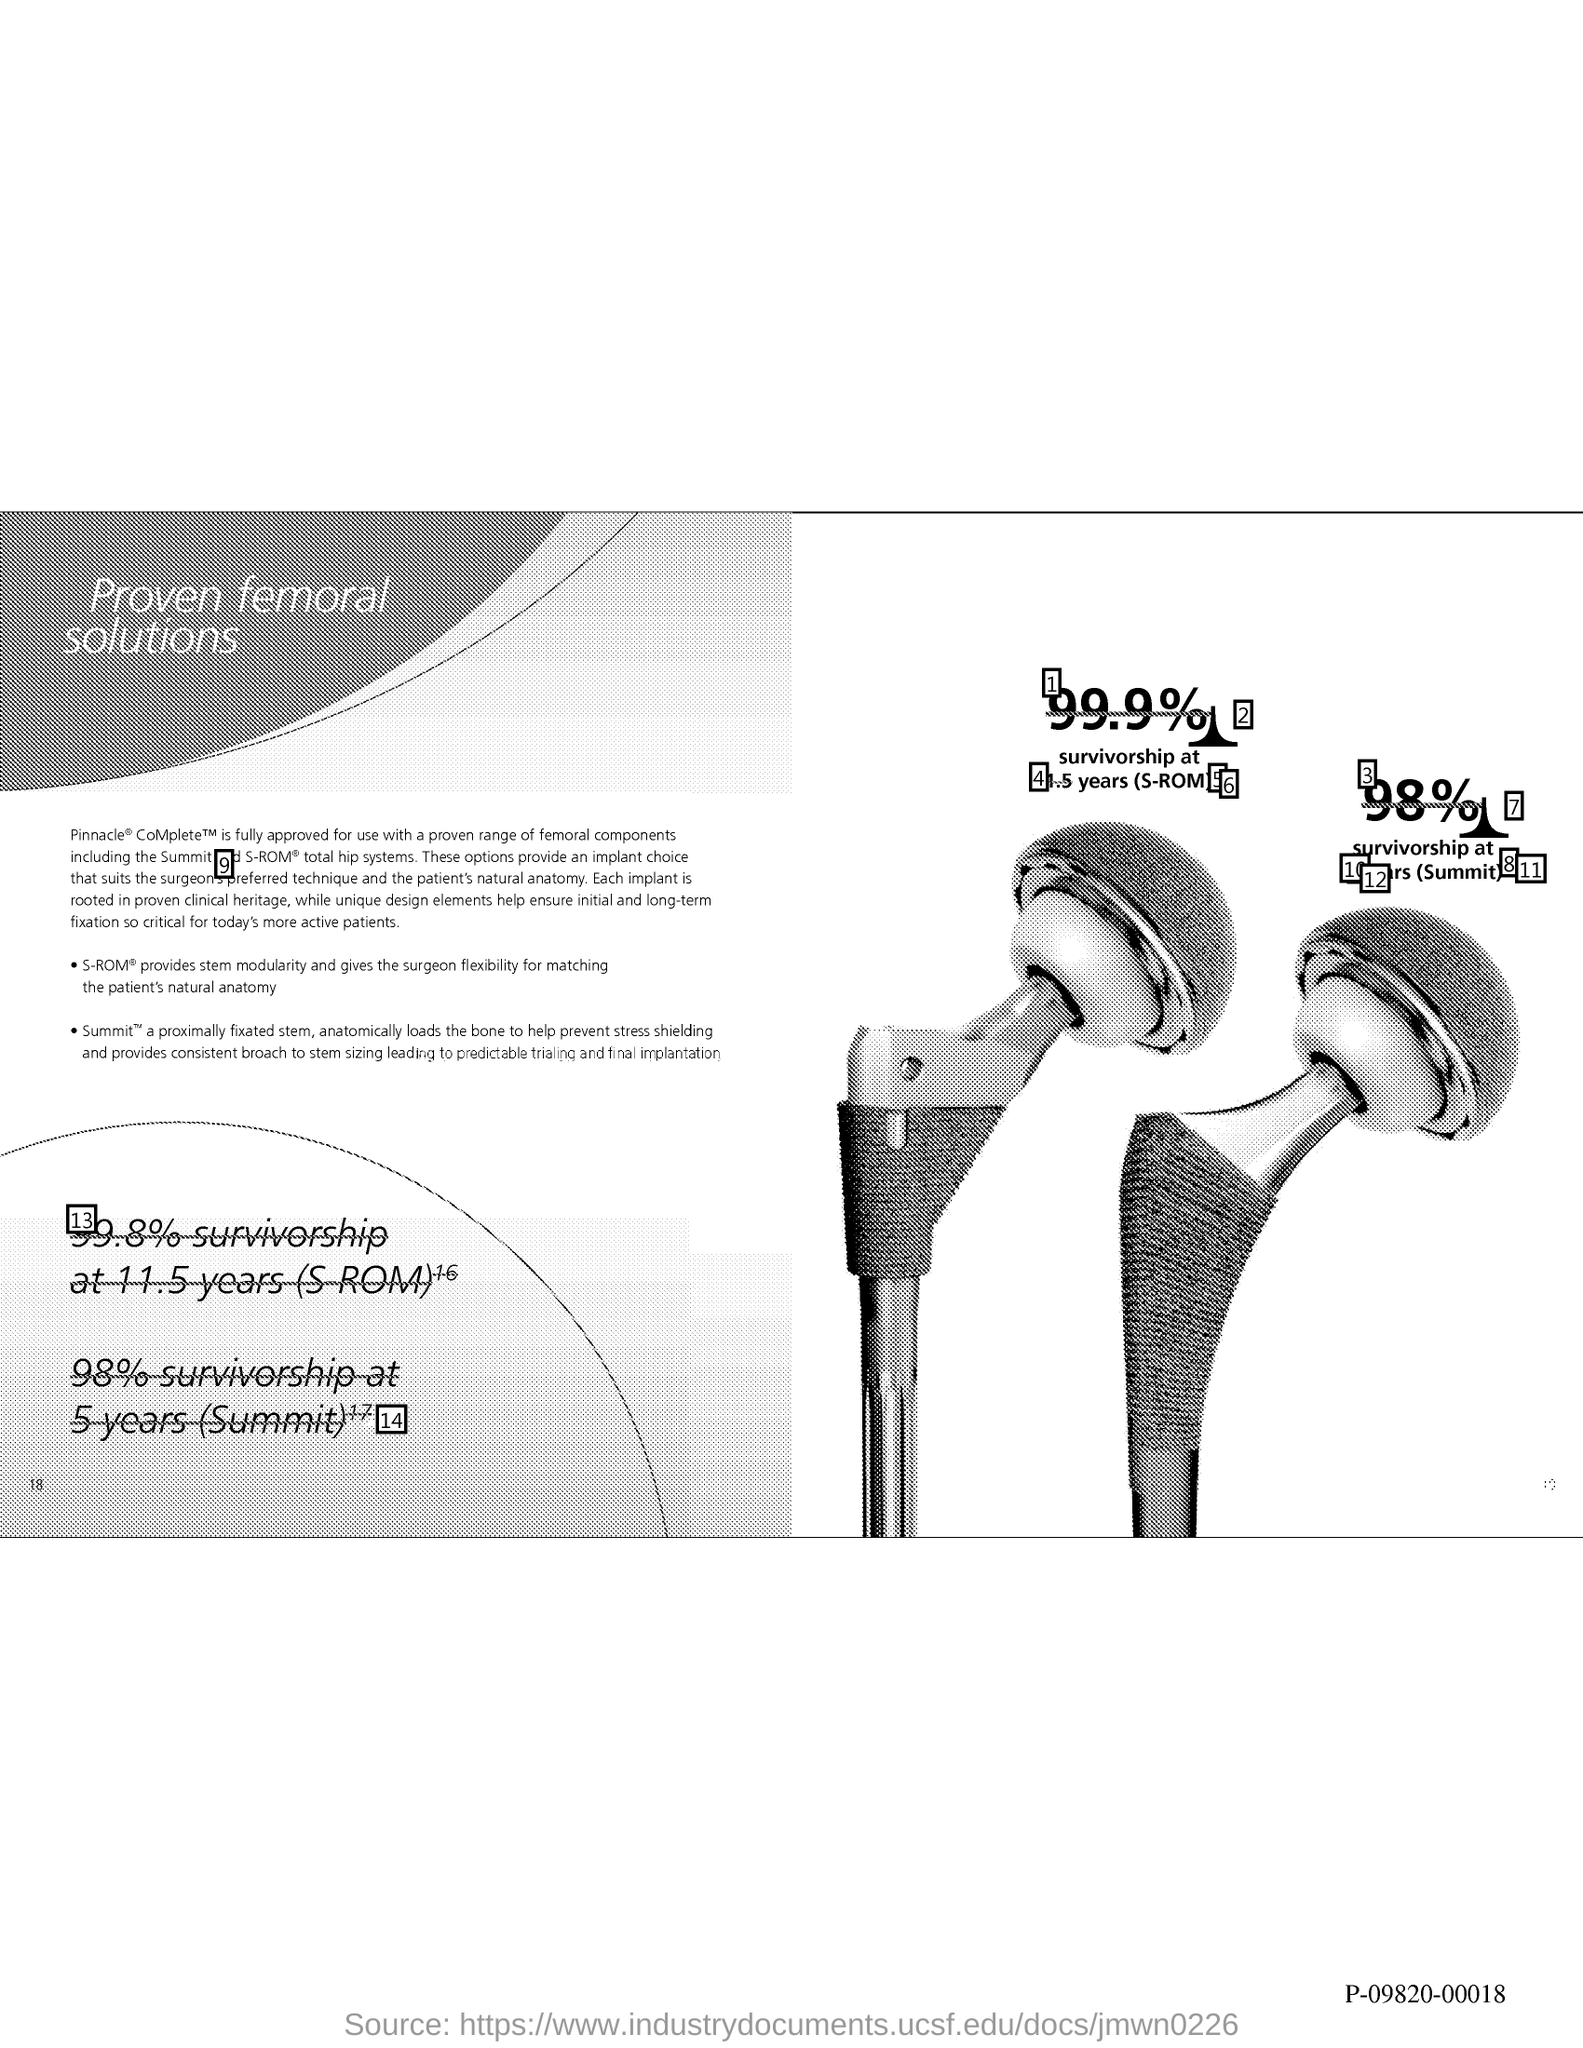What is the title of the document?
Offer a very short reply. Proven femoral solutions. 